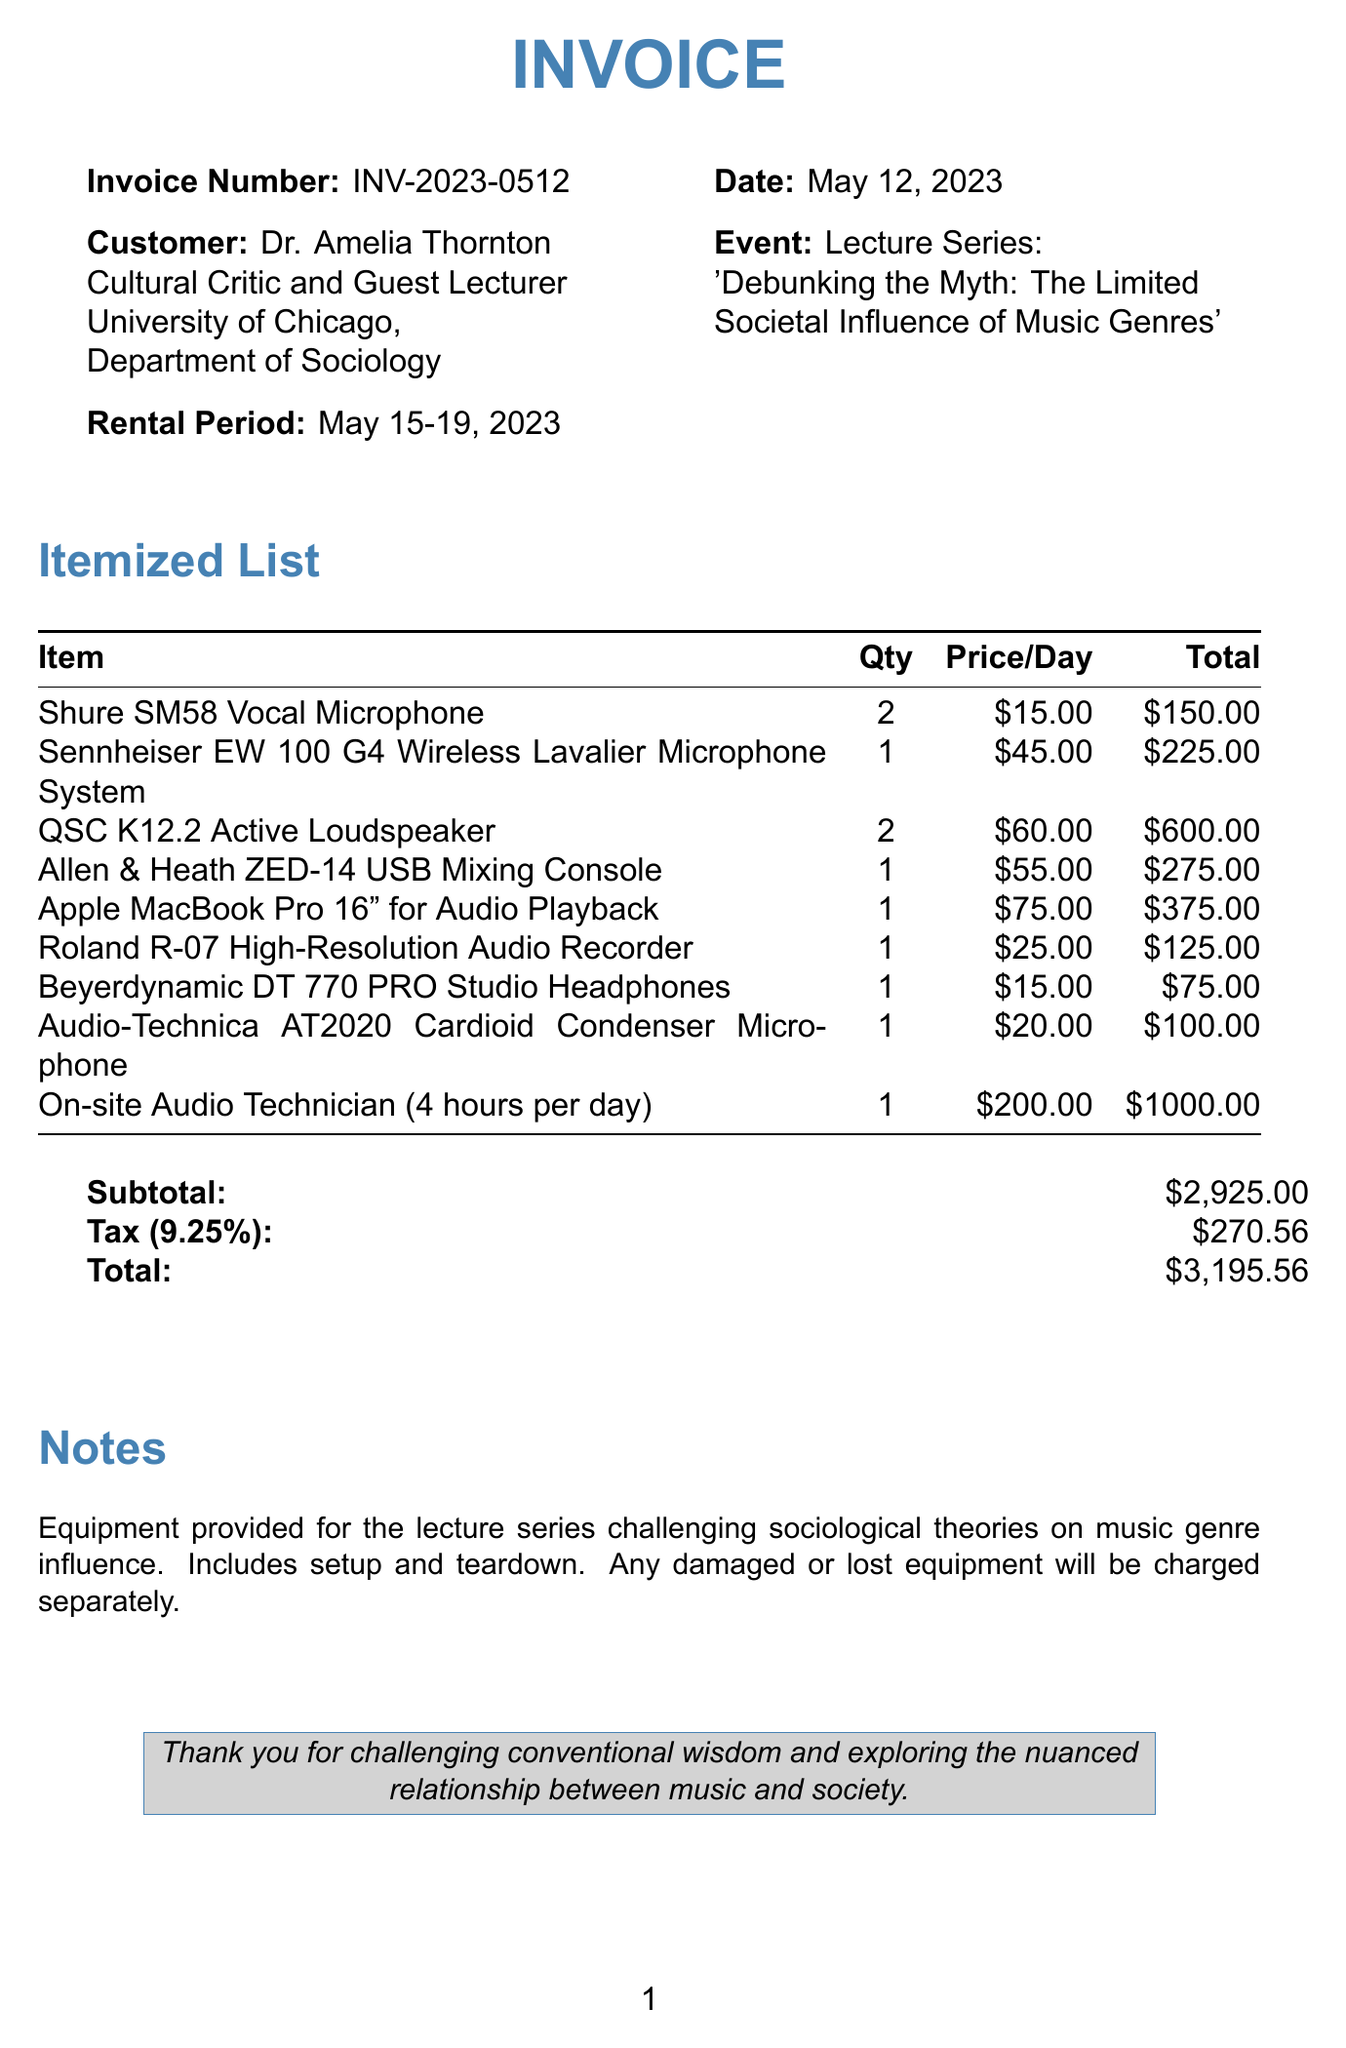What is the invoice number? The invoice number can be found at the top of the document.
Answer: INV-2023-0512 What is the rental period? The rental period is listed in the invoice details.
Answer: May 15-19, 2023 Who is the customer? The document specifies the name and title of the customer.
Answer: Dr. Amelia Thornton What is the total amount on the invoice? The total amount is indicated in the financial summary at the bottom.
Answer: $3,195.56 How many Shure SM58 Vocal Microphones were rented? The quantity of this item is shown in the itemized list.
Answer: 2 What is the price per day for the Sennheiser EW 100 G4 Wireless Lavalier Microphone System? This information can be found in the itemized list for that item.
Answer: $45.00 What is the subtotal before tax? The subtotal is mentioned in the financial summary section of the document.
Answer: $2,925.00 What service duration is provided for the On-site Audio Technician? The duration of service can be found in the description of this rental item.
Answer: 4 hours per day What is noted regarding equipment damage or loss? This information is provided in the notes section of the invoice.
Answer: Any damaged or lost equipment will be charged separately 